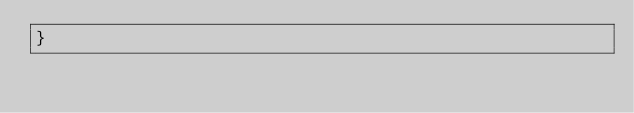Convert code to text. <code><loc_0><loc_0><loc_500><loc_500><_TypeScript_>}
</code> 